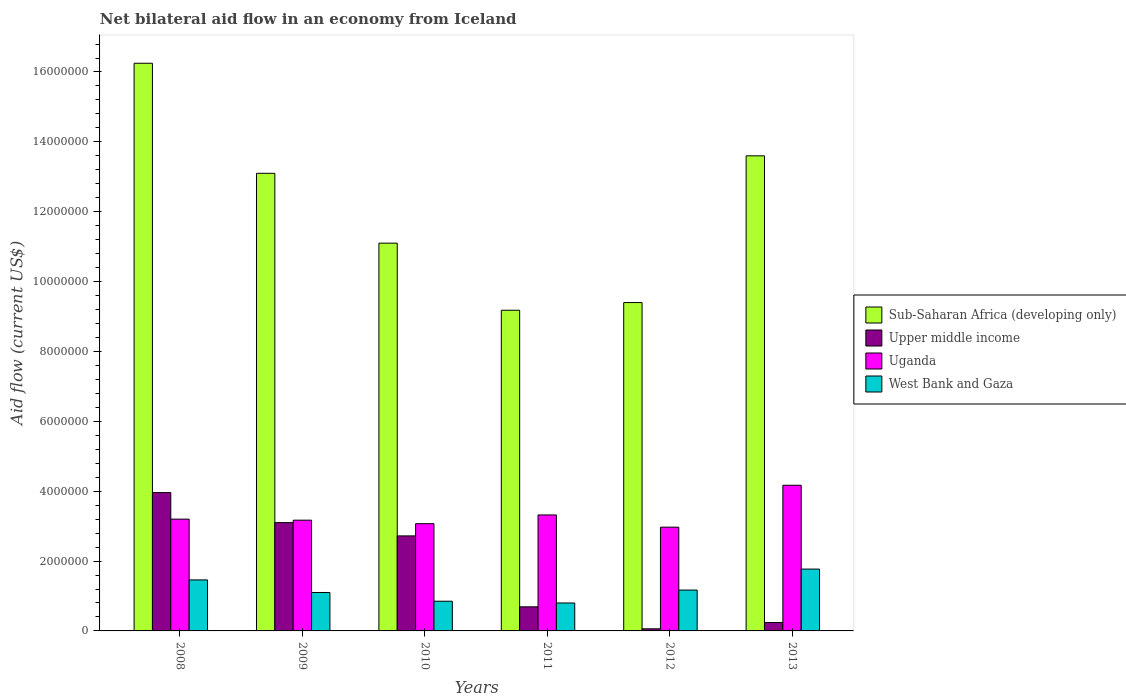How many groups of bars are there?
Your answer should be very brief. 6. Are the number of bars on each tick of the X-axis equal?
Give a very brief answer. Yes. How many bars are there on the 2nd tick from the left?
Make the answer very short. 4. In how many cases, is the number of bars for a given year not equal to the number of legend labels?
Give a very brief answer. 0. What is the net bilateral aid flow in Uganda in 2012?
Keep it short and to the point. 2.97e+06. Across all years, what is the maximum net bilateral aid flow in West Bank and Gaza?
Offer a very short reply. 1.77e+06. Across all years, what is the minimum net bilateral aid flow in West Bank and Gaza?
Give a very brief answer. 8.00e+05. In which year was the net bilateral aid flow in West Bank and Gaza minimum?
Offer a very short reply. 2011. What is the total net bilateral aid flow in West Bank and Gaza in the graph?
Your response must be concise. 7.15e+06. What is the difference between the net bilateral aid flow in Sub-Saharan Africa (developing only) in 2009 and that in 2011?
Make the answer very short. 3.92e+06. What is the difference between the net bilateral aid flow in Sub-Saharan Africa (developing only) in 2008 and the net bilateral aid flow in Uganda in 2013?
Offer a very short reply. 1.21e+07. What is the average net bilateral aid flow in Sub-Saharan Africa (developing only) per year?
Provide a succinct answer. 1.21e+07. In the year 2012, what is the difference between the net bilateral aid flow in Uganda and net bilateral aid flow in Sub-Saharan Africa (developing only)?
Make the answer very short. -6.43e+06. What is the ratio of the net bilateral aid flow in Uganda in 2009 to that in 2010?
Ensure brevity in your answer.  1.03. Is the net bilateral aid flow in Sub-Saharan Africa (developing only) in 2008 less than that in 2013?
Make the answer very short. No. What is the difference between the highest and the second highest net bilateral aid flow in Upper middle income?
Provide a succinct answer. 8.60e+05. What is the difference between the highest and the lowest net bilateral aid flow in West Bank and Gaza?
Your answer should be compact. 9.70e+05. In how many years, is the net bilateral aid flow in Sub-Saharan Africa (developing only) greater than the average net bilateral aid flow in Sub-Saharan Africa (developing only) taken over all years?
Make the answer very short. 3. Is the sum of the net bilateral aid flow in Upper middle income in 2008 and 2012 greater than the maximum net bilateral aid flow in Uganda across all years?
Offer a very short reply. No. What does the 4th bar from the left in 2008 represents?
Your response must be concise. West Bank and Gaza. What does the 1st bar from the right in 2008 represents?
Offer a very short reply. West Bank and Gaza. Is it the case that in every year, the sum of the net bilateral aid flow in Sub-Saharan Africa (developing only) and net bilateral aid flow in West Bank and Gaza is greater than the net bilateral aid flow in Upper middle income?
Provide a succinct answer. Yes. How many bars are there?
Provide a short and direct response. 24. Are all the bars in the graph horizontal?
Your response must be concise. No. What is the difference between two consecutive major ticks on the Y-axis?
Make the answer very short. 2.00e+06. How are the legend labels stacked?
Ensure brevity in your answer.  Vertical. What is the title of the graph?
Offer a very short reply. Net bilateral aid flow in an economy from Iceland. Does "Russian Federation" appear as one of the legend labels in the graph?
Give a very brief answer. No. What is the label or title of the X-axis?
Keep it short and to the point. Years. What is the label or title of the Y-axis?
Your answer should be very brief. Aid flow (current US$). What is the Aid flow (current US$) of Sub-Saharan Africa (developing only) in 2008?
Your answer should be compact. 1.62e+07. What is the Aid flow (current US$) in Upper middle income in 2008?
Provide a succinct answer. 3.96e+06. What is the Aid flow (current US$) in Uganda in 2008?
Give a very brief answer. 3.20e+06. What is the Aid flow (current US$) of West Bank and Gaza in 2008?
Your response must be concise. 1.46e+06. What is the Aid flow (current US$) in Sub-Saharan Africa (developing only) in 2009?
Offer a terse response. 1.31e+07. What is the Aid flow (current US$) in Upper middle income in 2009?
Make the answer very short. 3.10e+06. What is the Aid flow (current US$) in Uganda in 2009?
Ensure brevity in your answer.  3.17e+06. What is the Aid flow (current US$) in West Bank and Gaza in 2009?
Keep it short and to the point. 1.10e+06. What is the Aid flow (current US$) in Sub-Saharan Africa (developing only) in 2010?
Offer a very short reply. 1.11e+07. What is the Aid flow (current US$) in Upper middle income in 2010?
Provide a succinct answer. 2.72e+06. What is the Aid flow (current US$) of Uganda in 2010?
Ensure brevity in your answer.  3.07e+06. What is the Aid flow (current US$) in West Bank and Gaza in 2010?
Provide a succinct answer. 8.50e+05. What is the Aid flow (current US$) in Sub-Saharan Africa (developing only) in 2011?
Offer a terse response. 9.18e+06. What is the Aid flow (current US$) in Upper middle income in 2011?
Offer a very short reply. 6.90e+05. What is the Aid flow (current US$) in Uganda in 2011?
Your answer should be very brief. 3.32e+06. What is the Aid flow (current US$) of Sub-Saharan Africa (developing only) in 2012?
Ensure brevity in your answer.  9.40e+06. What is the Aid flow (current US$) in Upper middle income in 2012?
Your answer should be very brief. 6.00e+04. What is the Aid flow (current US$) of Uganda in 2012?
Your answer should be compact. 2.97e+06. What is the Aid flow (current US$) of West Bank and Gaza in 2012?
Offer a terse response. 1.17e+06. What is the Aid flow (current US$) of Sub-Saharan Africa (developing only) in 2013?
Keep it short and to the point. 1.36e+07. What is the Aid flow (current US$) in Upper middle income in 2013?
Ensure brevity in your answer.  2.40e+05. What is the Aid flow (current US$) in Uganda in 2013?
Your response must be concise. 4.17e+06. What is the Aid flow (current US$) of West Bank and Gaza in 2013?
Your answer should be compact. 1.77e+06. Across all years, what is the maximum Aid flow (current US$) of Sub-Saharan Africa (developing only)?
Give a very brief answer. 1.62e+07. Across all years, what is the maximum Aid flow (current US$) of Upper middle income?
Make the answer very short. 3.96e+06. Across all years, what is the maximum Aid flow (current US$) in Uganda?
Provide a succinct answer. 4.17e+06. Across all years, what is the maximum Aid flow (current US$) in West Bank and Gaza?
Your answer should be very brief. 1.77e+06. Across all years, what is the minimum Aid flow (current US$) of Sub-Saharan Africa (developing only)?
Give a very brief answer. 9.18e+06. Across all years, what is the minimum Aid flow (current US$) in Uganda?
Keep it short and to the point. 2.97e+06. What is the total Aid flow (current US$) of Sub-Saharan Africa (developing only) in the graph?
Your response must be concise. 7.26e+07. What is the total Aid flow (current US$) in Upper middle income in the graph?
Make the answer very short. 1.08e+07. What is the total Aid flow (current US$) of Uganda in the graph?
Your answer should be compact. 1.99e+07. What is the total Aid flow (current US$) in West Bank and Gaza in the graph?
Make the answer very short. 7.15e+06. What is the difference between the Aid flow (current US$) in Sub-Saharan Africa (developing only) in 2008 and that in 2009?
Give a very brief answer. 3.15e+06. What is the difference between the Aid flow (current US$) in Upper middle income in 2008 and that in 2009?
Your response must be concise. 8.60e+05. What is the difference between the Aid flow (current US$) in Uganda in 2008 and that in 2009?
Offer a terse response. 3.00e+04. What is the difference between the Aid flow (current US$) in Sub-Saharan Africa (developing only) in 2008 and that in 2010?
Keep it short and to the point. 5.15e+06. What is the difference between the Aid flow (current US$) in Upper middle income in 2008 and that in 2010?
Provide a succinct answer. 1.24e+06. What is the difference between the Aid flow (current US$) in West Bank and Gaza in 2008 and that in 2010?
Offer a terse response. 6.10e+05. What is the difference between the Aid flow (current US$) of Sub-Saharan Africa (developing only) in 2008 and that in 2011?
Make the answer very short. 7.07e+06. What is the difference between the Aid flow (current US$) of Upper middle income in 2008 and that in 2011?
Provide a short and direct response. 3.27e+06. What is the difference between the Aid flow (current US$) of Uganda in 2008 and that in 2011?
Ensure brevity in your answer.  -1.20e+05. What is the difference between the Aid flow (current US$) of Sub-Saharan Africa (developing only) in 2008 and that in 2012?
Offer a terse response. 6.85e+06. What is the difference between the Aid flow (current US$) of Upper middle income in 2008 and that in 2012?
Give a very brief answer. 3.90e+06. What is the difference between the Aid flow (current US$) of Sub-Saharan Africa (developing only) in 2008 and that in 2013?
Give a very brief answer. 2.65e+06. What is the difference between the Aid flow (current US$) of Upper middle income in 2008 and that in 2013?
Your answer should be very brief. 3.72e+06. What is the difference between the Aid flow (current US$) of Uganda in 2008 and that in 2013?
Offer a terse response. -9.70e+05. What is the difference between the Aid flow (current US$) in West Bank and Gaza in 2008 and that in 2013?
Offer a very short reply. -3.10e+05. What is the difference between the Aid flow (current US$) in Upper middle income in 2009 and that in 2010?
Your response must be concise. 3.80e+05. What is the difference between the Aid flow (current US$) of Uganda in 2009 and that in 2010?
Your response must be concise. 1.00e+05. What is the difference between the Aid flow (current US$) of West Bank and Gaza in 2009 and that in 2010?
Your response must be concise. 2.50e+05. What is the difference between the Aid flow (current US$) of Sub-Saharan Africa (developing only) in 2009 and that in 2011?
Make the answer very short. 3.92e+06. What is the difference between the Aid flow (current US$) of Upper middle income in 2009 and that in 2011?
Make the answer very short. 2.41e+06. What is the difference between the Aid flow (current US$) in Uganda in 2009 and that in 2011?
Offer a terse response. -1.50e+05. What is the difference between the Aid flow (current US$) in West Bank and Gaza in 2009 and that in 2011?
Keep it short and to the point. 3.00e+05. What is the difference between the Aid flow (current US$) in Sub-Saharan Africa (developing only) in 2009 and that in 2012?
Offer a terse response. 3.70e+06. What is the difference between the Aid flow (current US$) in Upper middle income in 2009 and that in 2012?
Your answer should be very brief. 3.04e+06. What is the difference between the Aid flow (current US$) of West Bank and Gaza in 2009 and that in 2012?
Give a very brief answer. -7.00e+04. What is the difference between the Aid flow (current US$) in Sub-Saharan Africa (developing only) in 2009 and that in 2013?
Keep it short and to the point. -5.00e+05. What is the difference between the Aid flow (current US$) of Upper middle income in 2009 and that in 2013?
Ensure brevity in your answer.  2.86e+06. What is the difference between the Aid flow (current US$) of Uganda in 2009 and that in 2013?
Provide a succinct answer. -1.00e+06. What is the difference between the Aid flow (current US$) of West Bank and Gaza in 2009 and that in 2013?
Your answer should be very brief. -6.70e+05. What is the difference between the Aid flow (current US$) in Sub-Saharan Africa (developing only) in 2010 and that in 2011?
Give a very brief answer. 1.92e+06. What is the difference between the Aid flow (current US$) in Upper middle income in 2010 and that in 2011?
Give a very brief answer. 2.03e+06. What is the difference between the Aid flow (current US$) in West Bank and Gaza in 2010 and that in 2011?
Offer a very short reply. 5.00e+04. What is the difference between the Aid flow (current US$) of Sub-Saharan Africa (developing only) in 2010 and that in 2012?
Your answer should be compact. 1.70e+06. What is the difference between the Aid flow (current US$) of Upper middle income in 2010 and that in 2012?
Offer a very short reply. 2.66e+06. What is the difference between the Aid flow (current US$) of West Bank and Gaza in 2010 and that in 2012?
Ensure brevity in your answer.  -3.20e+05. What is the difference between the Aid flow (current US$) of Sub-Saharan Africa (developing only) in 2010 and that in 2013?
Offer a terse response. -2.50e+06. What is the difference between the Aid flow (current US$) of Upper middle income in 2010 and that in 2013?
Give a very brief answer. 2.48e+06. What is the difference between the Aid flow (current US$) of Uganda in 2010 and that in 2013?
Offer a very short reply. -1.10e+06. What is the difference between the Aid flow (current US$) of West Bank and Gaza in 2010 and that in 2013?
Keep it short and to the point. -9.20e+05. What is the difference between the Aid flow (current US$) of Sub-Saharan Africa (developing only) in 2011 and that in 2012?
Your answer should be compact. -2.20e+05. What is the difference between the Aid flow (current US$) in Upper middle income in 2011 and that in 2012?
Offer a terse response. 6.30e+05. What is the difference between the Aid flow (current US$) in West Bank and Gaza in 2011 and that in 2012?
Your response must be concise. -3.70e+05. What is the difference between the Aid flow (current US$) of Sub-Saharan Africa (developing only) in 2011 and that in 2013?
Give a very brief answer. -4.42e+06. What is the difference between the Aid flow (current US$) in Upper middle income in 2011 and that in 2013?
Offer a terse response. 4.50e+05. What is the difference between the Aid flow (current US$) of Uganda in 2011 and that in 2013?
Offer a very short reply. -8.50e+05. What is the difference between the Aid flow (current US$) in West Bank and Gaza in 2011 and that in 2013?
Make the answer very short. -9.70e+05. What is the difference between the Aid flow (current US$) in Sub-Saharan Africa (developing only) in 2012 and that in 2013?
Make the answer very short. -4.20e+06. What is the difference between the Aid flow (current US$) in Uganda in 2012 and that in 2013?
Your response must be concise. -1.20e+06. What is the difference between the Aid flow (current US$) of West Bank and Gaza in 2012 and that in 2013?
Provide a short and direct response. -6.00e+05. What is the difference between the Aid flow (current US$) of Sub-Saharan Africa (developing only) in 2008 and the Aid flow (current US$) of Upper middle income in 2009?
Provide a short and direct response. 1.32e+07. What is the difference between the Aid flow (current US$) in Sub-Saharan Africa (developing only) in 2008 and the Aid flow (current US$) in Uganda in 2009?
Your response must be concise. 1.31e+07. What is the difference between the Aid flow (current US$) in Sub-Saharan Africa (developing only) in 2008 and the Aid flow (current US$) in West Bank and Gaza in 2009?
Provide a succinct answer. 1.52e+07. What is the difference between the Aid flow (current US$) of Upper middle income in 2008 and the Aid flow (current US$) of Uganda in 2009?
Keep it short and to the point. 7.90e+05. What is the difference between the Aid flow (current US$) of Upper middle income in 2008 and the Aid flow (current US$) of West Bank and Gaza in 2009?
Keep it short and to the point. 2.86e+06. What is the difference between the Aid flow (current US$) of Uganda in 2008 and the Aid flow (current US$) of West Bank and Gaza in 2009?
Give a very brief answer. 2.10e+06. What is the difference between the Aid flow (current US$) in Sub-Saharan Africa (developing only) in 2008 and the Aid flow (current US$) in Upper middle income in 2010?
Your answer should be very brief. 1.35e+07. What is the difference between the Aid flow (current US$) in Sub-Saharan Africa (developing only) in 2008 and the Aid flow (current US$) in Uganda in 2010?
Ensure brevity in your answer.  1.32e+07. What is the difference between the Aid flow (current US$) in Sub-Saharan Africa (developing only) in 2008 and the Aid flow (current US$) in West Bank and Gaza in 2010?
Make the answer very short. 1.54e+07. What is the difference between the Aid flow (current US$) in Upper middle income in 2008 and the Aid flow (current US$) in Uganda in 2010?
Provide a succinct answer. 8.90e+05. What is the difference between the Aid flow (current US$) of Upper middle income in 2008 and the Aid flow (current US$) of West Bank and Gaza in 2010?
Provide a succinct answer. 3.11e+06. What is the difference between the Aid flow (current US$) in Uganda in 2008 and the Aid flow (current US$) in West Bank and Gaza in 2010?
Offer a very short reply. 2.35e+06. What is the difference between the Aid flow (current US$) of Sub-Saharan Africa (developing only) in 2008 and the Aid flow (current US$) of Upper middle income in 2011?
Your response must be concise. 1.56e+07. What is the difference between the Aid flow (current US$) of Sub-Saharan Africa (developing only) in 2008 and the Aid flow (current US$) of Uganda in 2011?
Offer a very short reply. 1.29e+07. What is the difference between the Aid flow (current US$) in Sub-Saharan Africa (developing only) in 2008 and the Aid flow (current US$) in West Bank and Gaza in 2011?
Your answer should be compact. 1.54e+07. What is the difference between the Aid flow (current US$) in Upper middle income in 2008 and the Aid flow (current US$) in Uganda in 2011?
Provide a short and direct response. 6.40e+05. What is the difference between the Aid flow (current US$) in Upper middle income in 2008 and the Aid flow (current US$) in West Bank and Gaza in 2011?
Keep it short and to the point. 3.16e+06. What is the difference between the Aid flow (current US$) in Uganda in 2008 and the Aid flow (current US$) in West Bank and Gaza in 2011?
Provide a short and direct response. 2.40e+06. What is the difference between the Aid flow (current US$) in Sub-Saharan Africa (developing only) in 2008 and the Aid flow (current US$) in Upper middle income in 2012?
Your answer should be compact. 1.62e+07. What is the difference between the Aid flow (current US$) of Sub-Saharan Africa (developing only) in 2008 and the Aid flow (current US$) of Uganda in 2012?
Your answer should be compact. 1.33e+07. What is the difference between the Aid flow (current US$) in Sub-Saharan Africa (developing only) in 2008 and the Aid flow (current US$) in West Bank and Gaza in 2012?
Ensure brevity in your answer.  1.51e+07. What is the difference between the Aid flow (current US$) of Upper middle income in 2008 and the Aid flow (current US$) of Uganda in 2012?
Keep it short and to the point. 9.90e+05. What is the difference between the Aid flow (current US$) in Upper middle income in 2008 and the Aid flow (current US$) in West Bank and Gaza in 2012?
Provide a succinct answer. 2.79e+06. What is the difference between the Aid flow (current US$) in Uganda in 2008 and the Aid flow (current US$) in West Bank and Gaza in 2012?
Your response must be concise. 2.03e+06. What is the difference between the Aid flow (current US$) in Sub-Saharan Africa (developing only) in 2008 and the Aid flow (current US$) in Upper middle income in 2013?
Keep it short and to the point. 1.60e+07. What is the difference between the Aid flow (current US$) of Sub-Saharan Africa (developing only) in 2008 and the Aid flow (current US$) of Uganda in 2013?
Make the answer very short. 1.21e+07. What is the difference between the Aid flow (current US$) in Sub-Saharan Africa (developing only) in 2008 and the Aid flow (current US$) in West Bank and Gaza in 2013?
Give a very brief answer. 1.45e+07. What is the difference between the Aid flow (current US$) in Upper middle income in 2008 and the Aid flow (current US$) in West Bank and Gaza in 2013?
Ensure brevity in your answer.  2.19e+06. What is the difference between the Aid flow (current US$) in Uganda in 2008 and the Aid flow (current US$) in West Bank and Gaza in 2013?
Offer a very short reply. 1.43e+06. What is the difference between the Aid flow (current US$) in Sub-Saharan Africa (developing only) in 2009 and the Aid flow (current US$) in Upper middle income in 2010?
Make the answer very short. 1.04e+07. What is the difference between the Aid flow (current US$) of Sub-Saharan Africa (developing only) in 2009 and the Aid flow (current US$) of Uganda in 2010?
Offer a terse response. 1.00e+07. What is the difference between the Aid flow (current US$) of Sub-Saharan Africa (developing only) in 2009 and the Aid flow (current US$) of West Bank and Gaza in 2010?
Ensure brevity in your answer.  1.22e+07. What is the difference between the Aid flow (current US$) of Upper middle income in 2009 and the Aid flow (current US$) of Uganda in 2010?
Provide a succinct answer. 3.00e+04. What is the difference between the Aid flow (current US$) in Upper middle income in 2009 and the Aid flow (current US$) in West Bank and Gaza in 2010?
Ensure brevity in your answer.  2.25e+06. What is the difference between the Aid flow (current US$) of Uganda in 2009 and the Aid flow (current US$) of West Bank and Gaza in 2010?
Provide a short and direct response. 2.32e+06. What is the difference between the Aid flow (current US$) in Sub-Saharan Africa (developing only) in 2009 and the Aid flow (current US$) in Upper middle income in 2011?
Your response must be concise. 1.24e+07. What is the difference between the Aid flow (current US$) of Sub-Saharan Africa (developing only) in 2009 and the Aid flow (current US$) of Uganda in 2011?
Give a very brief answer. 9.78e+06. What is the difference between the Aid flow (current US$) of Sub-Saharan Africa (developing only) in 2009 and the Aid flow (current US$) of West Bank and Gaza in 2011?
Ensure brevity in your answer.  1.23e+07. What is the difference between the Aid flow (current US$) in Upper middle income in 2009 and the Aid flow (current US$) in Uganda in 2011?
Make the answer very short. -2.20e+05. What is the difference between the Aid flow (current US$) in Upper middle income in 2009 and the Aid flow (current US$) in West Bank and Gaza in 2011?
Offer a very short reply. 2.30e+06. What is the difference between the Aid flow (current US$) in Uganda in 2009 and the Aid flow (current US$) in West Bank and Gaza in 2011?
Your response must be concise. 2.37e+06. What is the difference between the Aid flow (current US$) of Sub-Saharan Africa (developing only) in 2009 and the Aid flow (current US$) of Upper middle income in 2012?
Provide a succinct answer. 1.30e+07. What is the difference between the Aid flow (current US$) in Sub-Saharan Africa (developing only) in 2009 and the Aid flow (current US$) in Uganda in 2012?
Your answer should be compact. 1.01e+07. What is the difference between the Aid flow (current US$) of Sub-Saharan Africa (developing only) in 2009 and the Aid flow (current US$) of West Bank and Gaza in 2012?
Provide a succinct answer. 1.19e+07. What is the difference between the Aid flow (current US$) in Upper middle income in 2009 and the Aid flow (current US$) in West Bank and Gaza in 2012?
Ensure brevity in your answer.  1.93e+06. What is the difference between the Aid flow (current US$) of Uganda in 2009 and the Aid flow (current US$) of West Bank and Gaza in 2012?
Keep it short and to the point. 2.00e+06. What is the difference between the Aid flow (current US$) of Sub-Saharan Africa (developing only) in 2009 and the Aid flow (current US$) of Upper middle income in 2013?
Your answer should be very brief. 1.29e+07. What is the difference between the Aid flow (current US$) in Sub-Saharan Africa (developing only) in 2009 and the Aid flow (current US$) in Uganda in 2013?
Make the answer very short. 8.93e+06. What is the difference between the Aid flow (current US$) in Sub-Saharan Africa (developing only) in 2009 and the Aid flow (current US$) in West Bank and Gaza in 2013?
Offer a very short reply. 1.13e+07. What is the difference between the Aid flow (current US$) of Upper middle income in 2009 and the Aid flow (current US$) of Uganda in 2013?
Keep it short and to the point. -1.07e+06. What is the difference between the Aid flow (current US$) of Upper middle income in 2009 and the Aid flow (current US$) of West Bank and Gaza in 2013?
Ensure brevity in your answer.  1.33e+06. What is the difference between the Aid flow (current US$) in Uganda in 2009 and the Aid flow (current US$) in West Bank and Gaza in 2013?
Keep it short and to the point. 1.40e+06. What is the difference between the Aid flow (current US$) in Sub-Saharan Africa (developing only) in 2010 and the Aid flow (current US$) in Upper middle income in 2011?
Provide a short and direct response. 1.04e+07. What is the difference between the Aid flow (current US$) in Sub-Saharan Africa (developing only) in 2010 and the Aid flow (current US$) in Uganda in 2011?
Your response must be concise. 7.78e+06. What is the difference between the Aid flow (current US$) of Sub-Saharan Africa (developing only) in 2010 and the Aid flow (current US$) of West Bank and Gaza in 2011?
Give a very brief answer. 1.03e+07. What is the difference between the Aid flow (current US$) in Upper middle income in 2010 and the Aid flow (current US$) in Uganda in 2011?
Give a very brief answer. -6.00e+05. What is the difference between the Aid flow (current US$) of Upper middle income in 2010 and the Aid flow (current US$) of West Bank and Gaza in 2011?
Ensure brevity in your answer.  1.92e+06. What is the difference between the Aid flow (current US$) of Uganda in 2010 and the Aid flow (current US$) of West Bank and Gaza in 2011?
Offer a terse response. 2.27e+06. What is the difference between the Aid flow (current US$) in Sub-Saharan Africa (developing only) in 2010 and the Aid flow (current US$) in Upper middle income in 2012?
Provide a succinct answer. 1.10e+07. What is the difference between the Aid flow (current US$) of Sub-Saharan Africa (developing only) in 2010 and the Aid flow (current US$) of Uganda in 2012?
Ensure brevity in your answer.  8.13e+06. What is the difference between the Aid flow (current US$) in Sub-Saharan Africa (developing only) in 2010 and the Aid flow (current US$) in West Bank and Gaza in 2012?
Offer a terse response. 9.93e+06. What is the difference between the Aid flow (current US$) in Upper middle income in 2010 and the Aid flow (current US$) in Uganda in 2012?
Your answer should be very brief. -2.50e+05. What is the difference between the Aid flow (current US$) in Upper middle income in 2010 and the Aid flow (current US$) in West Bank and Gaza in 2012?
Give a very brief answer. 1.55e+06. What is the difference between the Aid flow (current US$) in Uganda in 2010 and the Aid flow (current US$) in West Bank and Gaza in 2012?
Your answer should be very brief. 1.90e+06. What is the difference between the Aid flow (current US$) of Sub-Saharan Africa (developing only) in 2010 and the Aid flow (current US$) of Upper middle income in 2013?
Ensure brevity in your answer.  1.09e+07. What is the difference between the Aid flow (current US$) of Sub-Saharan Africa (developing only) in 2010 and the Aid flow (current US$) of Uganda in 2013?
Offer a very short reply. 6.93e+06. What is the difference between the Aid flow (current US$) in Sub-Saharan Africa (developing only) in 2010 and the Aid flow (current US$) in West Bank and Gaza in 2013?
Offer a terse response. 9.33e+06. What is the difference between the Aid flow (current US$) of Upper middle income in 2010 and the Aid flow (current US$) of Uganda in 2013?
Provide a short and direct response. -1.45e+06. What is the difference between the Aid flow (current US$) of Upper middle income in 2010 and the Aid flow (current US$) of West Bank and Gaza in 2013?
Your answer should be very brief. 9.50e+05. What is the difference between the Aid flow (current US$) of Uganda in 2010 and the Aid flow (current US$) of West Bank and Gaza in 2013?
Your answer should be compact. 1.30e+06. What is the difference between the Aid flow (current US$) of Sub-Saharan Africa (developing only) in 2011 and the Aid flow (current US$) of Upper middle income in 2012?
Provide a succinct answer. 9.12e+06. What is the difference between the Aid flow (current US$) in Sub-Saharan Africa (developing only) in 2011 and the Aid flow (current US$) in Uganda in 2012?
Your response must be concise. 6.21e+06. What is the difference between the Aid flow (current US$) in Sub-Saharan Africa (developing only) in 2011 and the Aid flow (current US$) in West Bank and Gaza in 2012?
Keep it short and to the point. 8.01e+06. What is the difference between the Aid flow (current US$) in Upper middle income in 2011 and the Aid flow (current US$) in Uganda in 2012?
Offer a terse response. -2.28e+06. What is the difference between the Aid flow (current US$) in Upper middle income in 2011 and the Aid flow (current US$) in West Bank and Gaza in 2012?
Your response must be concise. -4.80e+05. What is the difference between the Aid flow (current US$) in Uganda in 2011 and the Aid flow (current US$) in West Bank and Gaza in 2012?
Your answer should be compact. 2.15e+06. What is the difference between the Aid flow (current US$) of Sub-Saharan Africa (developing only) in 2011 and the Aid flow (current US$) of Upper middle income in 2013?
Make the answer very short. 8.94e+06. What is the difference between the Aid flow (current US$) in Sub-Saharan Africa (developing only) in 2011 and the Aid flow (current US$) in Uganda in 2013?
Your answer should be very brief. 5.01e+06. What is the difference between the Aid flow (current US$) in Sub-Saharan Africa (developing only) in 2011 and the Aid flow (current US$) in West Bank and Gaza in 2013?
Your answer should be compact. 7.41e+06. What is the difference between the Aid flow (current US$) of Upper middle income in 2011 and the Aid flow (current US$) of Uganda in 2013?
Keep it short and to the point. -3.48e+06. What is the difference between the Aid flow (current US$) of Upper middle income in 2011 and the Aid flow (current US$) of West Bank and Gaza in 2013?
Make the answer very short. -1.08e+06. What is the difference between the Aid flow (current US$) in Uganda in 2011 and the Aid flow (current US$) in West Bank and Gaza in 2013?
Your response must be concise. 1.55e+06. What is the difference between the Aid flow (current US$) in Sub-Saharan Africa (developing only) in 2012 and the Aid flow (current US$) in Upper middle income in 2013?
Provide a succinct answer. 9.16e+06. What is the difference between the Aid flow (current US$) in Sub-Saharan Africa (developing only) in 2012 and the Aid flow (current US$) in Uganda in 2013?
Your answer should be compact. 5.23e+06. What is the difference between the Aid flow (current US$) of Sub-Saharan Africa (developing only) in 2012 and the Aid flow (current US$) of West Bank and Gaza in 2013?
Provide a short and direct response. 7.63e+06. What is the difference between the Aid flow (current US$) in Upper middle income in 2012 and the Aid flow (current US$) in Uganda in 2013?
Keep it short and to the point. -4.11e+06. What is the difference between the Aid flow (current US$) in Upper middle income in 2012 and the Aid flow (current US$) in West Bank and Gaza in 2013?
Your response must be concise. -1.71e+06. What is the difference between the Aid flow (current US$) in Uganda in 2012 and the Aid flow (current US$) in West Bank and Gaza in 2013?
Offer a very short reply. 1.20e+06. What is the average Aid flow (current US$) of Sub-Saharan Africa (developing only) per year?
Provide a succinct answer. 1.21e+07. What is the average Aid flow (current US$) of Upper middle income per year?
Keep it short and to the point. 1.80e+06. What is the average Aid flow (current US$) of Uganda per year?
Provide a short and direct response. 3.32e+06. What is the average Aid flow (current US$) in West Bank and Gaza per year?
Offer a very short reply. 1.19e+06. In the year 2008, what is the difference between the Aid flow (current US$) of Sub-Saharan Africa (developing only) and Aid flow (current US$) of Upper middle income?
Provide a succinct answer. 1.23e+07. In the year 2008, what is the difference between the Aid flow (current US$) in Sub-Saharan Africa (developing only) and Aid flow (current US$) in Uganda?
Keep it short and to the point. 1.30e+07. In the year 2008, what is the difference between the Aid flow (current US$) in Sub-Saharan Africa (developing only) and Aid flow (current US$) in West Bank and Gaza?
Your answer should be very brief. 1.48e+07. In the year 2008, what is the difference between the Aid flow (current US$) in Upper middle income and Aid flow (current US$) in Uganda?
Keep it short and to the point. 7.60e+05. In the year 2008, what is the difference between the Aid flow (current US$) of Upper middle income and Aid flow (current US$) of West Bank and Gaza?
Keep it short and to the point. 2.50e+06. In the year 2008, what is the difference between the Aid flow (current US$) of Uganda and Aid flow (current US$) of West Bank and Gaza?
Offer a terse response. 1.74e+06. In the year 2009, what is the difference between the Aid flow (current US$) of Sub-Saharan Africa (developing only) and Aid flow (current US$) of Upper middle income?
Ensure brevity in your answer.  1.00e+07. In the year 2009, what is the difference between the Aid flow (current US$) in Sub-Saharan Africa (developing only) and Aid flow (current US$) in Uganda?
Provide a succinct answer. 9.93e+06. In the year 2009, what is the difference between the Aid flow (current US$) of Uganda and Aid flow (current US$) of West Bank and Gaza?
Offer a terse response. 2.07e+06. In the year 2010, what is the difference between the Aid flow (current US$) of Sub-Saharan Africa (developing only) and Aid flow (current US$) of Upper middle income?
Provide a short and direct response. 8.38e+06. In the year 2010, what is the difference between the Aid flow (current US$) in Sub-Saharan Africa (developing only) and Aid flow (current US$) in Uganda?
Provide a succinct answer. 8.03e+06. In the year 2010, what is the difference between the Aid flow (current US$) in Sub-Saharan Africa (developing only) and Aid flow (current US$) in West Bank and Gaza?
Make the answer very short. 1.02e+07. In the year 2010, what is the difference between the Aid flow (current US$) in Upper middle income and Aid flow (current US$) in Uganda?
Offer a terse response. -3.50e+05. In the year 2010, what is the difference between the Aid flow (current US$) in Upper middle income and Aid flow (current US$) in West Bank and Gaza?
Keep it short and to the point. 1.87e+06. In the year 2010, what is the difference between the Aid flow (current US$) of Uganda and Aid flow (current US$) of West Bank and Gaza?
Ensure brevity in your answer.  2.22e+06. In the year 2011, what is the difference between the Aid flow (current US$) of Sub-Saharan Africa (developing only) and Aid flow (current US$) of Upper middle income?
Ensure brevity in your answer.  8.49e+06. In the year 2011, what is the difference between the Aid flow (current US$) in Sub-Saharan Africa (developing only) and Aid flow (current US$) in Uganda?
Offer a terse response. 5.86e+06. In the year 2011, what is the difference between the Aid flow (current US$) in Sub-Saharan Africa (developing only) and Aid flow (current US$) in West Bank and Gaza?
Ensure brevity in your answer.  8.38e+06. In the year 2011, what is the difference between the Aid flow (current US$) of Upper middle income and Aid flow (current US$) of Uganda?
Offer a terse response. -2.63e+06. In the year 2011, what is the difference between the Aid flow (current US$) of Uganda and Aid flow (current US$) of West Bank and Gaza?
Your answer should be very brief. 2.52e+06. In the year 2012, what is the difference between the Aid flow (current US$) of Sub-Saharan Africa (developing only) and Aid flow (current US$) of Upper middle income?
Your response must be concise. 9.34e+06. In the year 2012, what is the difference between the Aid flow (current US$) in Sub-Saharan Africa (developing only) and Aid flow (current US$) in Uganda?
Your response must be concise. 6.43e+06. In the year 2012, what is the difference between the Aid flow (current US$) in Sub-Saharan Africa (developing only) and Aid flow (current US$) in West Bank and Gaza?
Keep it short and to the point. 8.23e+06. In the year 2012, what is the difference between the Aid flow (current US$) in Upper middle income and Aid flow (current US$) in Uganda?
Give a very brief answer. -2.91e+06. In the year 2012, what is the difference between the Aid flow (current US$) of Upper middle income and Aid flow (current US$) of West Bank and Gaza?
Offer a very short reply. -1.11e+06. In the year 2012, what is the difference between the Aid flow (current US$) of Uganda and Aid flow (current US$) of West Bank and Gaza?
Make the answer very short. 1.80e+06. In the year 2013, what is the difference between the Aid flow (current US$) in Sub-Saharan Africa (developing only) and Aid flow (current US$) in Upper middle income?
Make the answer very short. 1.34e+07. In the year 2013, what is the difference between the Aid flow (current US$) of Sub-Saharan Africa (developing only) and Aid flow (current US$) of Uganda?
Provide a short and direct response. 9.43e+06. In the year 2013, what is the difference between the Aid flow (current US$) in Sub-Saharan Africa (developing only) and Aid flow (current US$) in West Bank and Gaza?
Your answer should be compact. 1.18e+07. In the year 2013, what is the difference between the Aid flow (current US$) in Upper middle income and Aid flow (current US$) in Uganda?
Provide a succinct answer. -3.93e+06. In the year 2013, what is the difference between the Aid flow (current US$) of Upper middle income and Aid flow (current US$) of West Bank and Gaza?
Your answer should be compact. -1.53e+06. In the year 2013, what is the difference between the Aid flow (current US$) in Uganda and Aid flow (current US$) in West Bank and Gaza?
Provide a short and direct response. 2.40e+06. What is the ratio of the Aid flow (current US$) of Sub-Saharan Africa (developing only) in 2008 to that in 2009?
Provide a short and direct response. 1.24. What is the ratio of the Aid flow (current US$) in Upper middle income in 2008 to that in 2009?
Offer a very short reply. 1.28. What is the ratio of the Aid flow (current US$) of Uganda in 2008 to that in 2009?
Provide a succinct answer. 1.01. What is the ratio of the Aid flow (current US$) of West Bank and Gaza in 2008 to that in 2009?
Make the answer very short. 1.33. What is the ratio of the Aid flow (current US$) in Sub-Saharan Africa (developing only) in 2008 to that in 2010?
Provide a succinct answer. 1.46. What is the ratio of the Aid flow (current US$) in Upper middle income in 2008 to that in 2010?
Give a very brief answer. 1.46. What is the ratio of the Aid flow (current US$) in Uganda in 2008 to that in 2010?
Offer a terse response. 1.04. What is the ratio of the Aid flow (current US$) in West Bank and Gaza in 2008 to that in 2010?
Your response must be concise. 1.72. What is the ratio of the Aid flow (current US$) in Sub-Saharan Africa (developing only) in 2008 to that in 2011?
Your answer should be very brief. 1.77. What is the ratio of the Aid flow (current US$) of Upper middle income in 2008 to that in 2011?
Your response must be concise. 5.74. What is the ratio of the Aid flow (current US$) in Uganda in 2008 to that in 2011?
Your answer should be very brief. 0.96. What is the ratio of the Aid flow (current US$) of West Bank and Gaza in 2008 to that in 2011?
Provide a short and direct response. 1.82. What is the ratio of the Aid flow (current US$) of Sub-Saharan Africa (developing only) in 2008 to that in 2012?
Your answer should be very brief. 1.73. What is the ratio of the Aid flow (current US$) of Uganda in 2008 to that in 2012?
Offer a terse response. 1.08. What is the ratio of the Aid flow (current US$) in West Bank and Gaza in 2008 to that in 2012?
Provide a short and direct response. 1.25. What is the ratio of the Aid flow (current US$) of Sub-Saharan Africa (developing only) in 2008 to that in 2013?
Your response must be concise. 1.19. What is the ratio of the Aid flow (current US$) in Upper middle income in 2008 to that in 2013?
Your answer should be very brief. 16.5. What is the ratio of the Aid flow (current US$) of Uganda in 2008 to that in 2013?
Your answer should be very brief. 0.77. What is the ratio of the Aid flow (current US$) in West Bank and Gaza in 2008 to that in 2013?
Ensure brevity in your answer.  0.82. What is the ratio of the Aid flow (current US$) of Sub-Saharan Africa (developing only) in 2009 to that in 2010?
Give a very brief answer. 1.18. What is the ratio of the Aid flow (current US$) of Upper middle income in 2009 to that in 2010?
Keep it short and to the point. 1.14. What is the ratio of the Aid flow (current US$) in Uganda in 2009 to that in 2010?
Your answer should be very brief. 1.03. What is the ratio of the Aid flow (current US$) in West Bank and Gaza in 2009 to that in 2010?
Keep it short and to the point. 1.29. What is the ratio of the Aid flow (current US$) of Sub-Saharan Africa (developing only) in 2009 to that in 2011?
Offer a terse response. 1.43. What is the ratio of the Aid flow (current US$) in Upper middle income in 2009 to that in 2011?
Provide a short and direct response. 4.49. What is the ratio of the Aid flow (current US$) of Uganda in 2009 to that in 2011?
Make the answer very short. 0.95. What is the ratio of the Aid flow (current US$) of West Bank and Gaza in 2009 to that in 2011?
Provide a succinct answer. 1.38. What is the ratio of the Aid flow (current US$) of Sub-Saharan Africa (developing only) in 2009 to that in 2012?
Give a very brief answer. 1.39. What is the ratio of the Aid flow (current US$) in Upper middle income in 2009 to that in 2012?
Your answer should be very brief. 51.67. What is the ratio of the Aid flow (current US$) of Uganda in 2009 to that in 2012?
Your answer should be very brief. 1.07. What is the ratio of the Aid flow (current US$) of West Bank and Gaza in 2009 to that in 2012?
Offer a very short reply. 0.94. What is the ratio of the Aid flow (current US$) in Sub-Saharan Africa (developing only) in 2009 to that in 2013?
Your response must be concise. 0.96. What is the ratio of the Aid flow (current US$) in Upper middle income in 2009 to that in 2013?
Give a very brief answer. 12.92. What is the ratio of the Aid flow (current US$) in Uganda in 2009 to that in 2013?
Make the answer very short. 0.76. What is the ratio of the Aid flow (current US$) of West Bank and Gaza in 2009 to that in 2013?
Ensure brevity in your answer.  0.62. What is the ratio of the Aid flow (current US$) of Sub-Saharan Africa (developing only) in 2010 to that in 2011?
Offer a very short reply. 1.21. What is the ratio of the Aid flow (current US$) of Upper middle income in 2010 to that in 2011?
Your answer should be very brief. 3.94. What is the ratio of the Aid flow (current US$) in Uganda in 2010 to that in 2011?
Your answer should be very brief. 0.92. What is the ratio of the Aid flow (current US$) of Sub-Saharan Africa (developing only) in 2010 to that in 2012?
Offer a terse response. 1.18. What is the ratio of the Aid flow (current US$) in Upper middle income in 2010 to that in 2012?
Offer a terse response. 45.33. What is the ratio of the Aid flow (current US$) of Uganda in 2010 to that in 2012?
Give a very brief answer. 1.03. What is the ratio of the Aid flow (current US$) in West Bank and Gaza in 2010 to that in 2012?
Your answer should be compact. 0.73. What is the ratio of the Aid flow (current US$) in Sub-Saharan Africa (developing only) in 2010 to that in 2013?
Make the answer very short. 0.82. What is the ratio of the Aid flow (current US$) of Upper middle income in 2010 to that in 2013?
Your answer should be very brief. 11.33. What is the ratio of the Aid flow (current US$) in Uganda in 2010 to that in 2013?
Your response must be concise. 0.74. What is the ratio of the Aid flow (current US$) in West Bank and Gaza in 2010 to that in 2013?
Provide a succinct answer. 0.48. What is the ratio of the Aid flow (current US$) in Sub-Saharan Africa (developing only) in 2011 to that in 2012?
Offer a terse response. 0.98. What is the ratio of the Aid flow (current US$) of Uganda in 2011 to that in 2012?
Offer a very short reply. 1.12. What is the ratio of the Aid flow (current US$) in West Bank and Gaza in 2011 to that in 2012?
Provide a short and direct response. 0.68. What is the ratio of the Aid flow (current US$) of Sub-Saharan Africa (developing only) in 2011 to that in 2013?
Offer a very short reply. 0.68. What is the ratio of the Aid flow (current US$) of Upper middle income in 2011 to that in 2013?
Make the answer very short. 2.88. What is the ratio of the Aid flow (current US$) in Uganda in 2011 to that in 2013?
Your response must be concise. 0.8. What is the ratio of the Aid flow (current US$) of West Bank and Gaza in 2011 to that in 2013?
Provide a short and direct response. 0.45. What is the ratio of the Aid flow (current US$) in Sub-Saharan Africa (developing only) in 2012 to that in 2013?
Keep it short and to the point. 0.69. What is the ratio of the Aid flow (current US$) in Upper middle income in 2012 to that in 2013?
Offer a very short reply. 0.25. What is the ratio of the Aid flow (current US$) in Uganda in 2012 to that in 2013?
Your answer should be very brief. 0.71. What is the ratio of the Aid flow (current US$) in West Bank and Gaza in 2012 to that in 2013?
Provide a short and direct response. 0.66. What is the difference between the highest and the second highest Aid flow (current US$) in Sub-Saharan Africa (developing only)?
Your response must be concise. 2.65e+06. What is the difference between the highest and the second highest Aid flow (current US$) of Upper middle income?
Offer a terse response. 8.60e+05. What is the difference between the highest and the second highest Aid flow (current US$) in Uganda?
Ensure brevity in your answer.  8.50e+05. What is the difference between the highest and the second highest Aid flow (current US$) in West Bank and Gaza?
Make the answer very short. 3.10e+05. What is the difference between the highest and the lowest Aid flow (current US$) in Sub-Saharan Africa (developing only)?
Ensure brevity in your answer.  7.07e+06. What is the difference between the highest and the lowest Aid flow (current US$) in Upper middle income?
Offer a very short reply. 3.90e+06. What is the difference between the highest and the lowest Aid flow (current US$) of Uganda?
Provide a succinct answer. 1.20e+06. What is the difference between the highest and the lowest Aid flow (current US$) in West Bank and Gaza?
Offer a very short reply. 9.70e+05. 